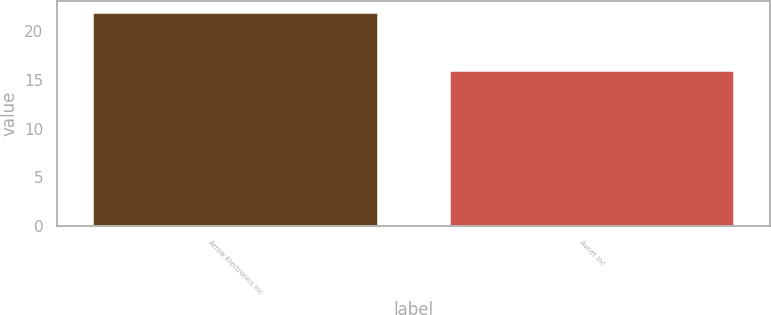<chart> <loc_0><loc_0><loc_500><loc_500><bar_chart><fcel>Arrow Electronics Inc<fcel>Avnet Inc<nl><fcel>22<fcel>16<nl></chart> 